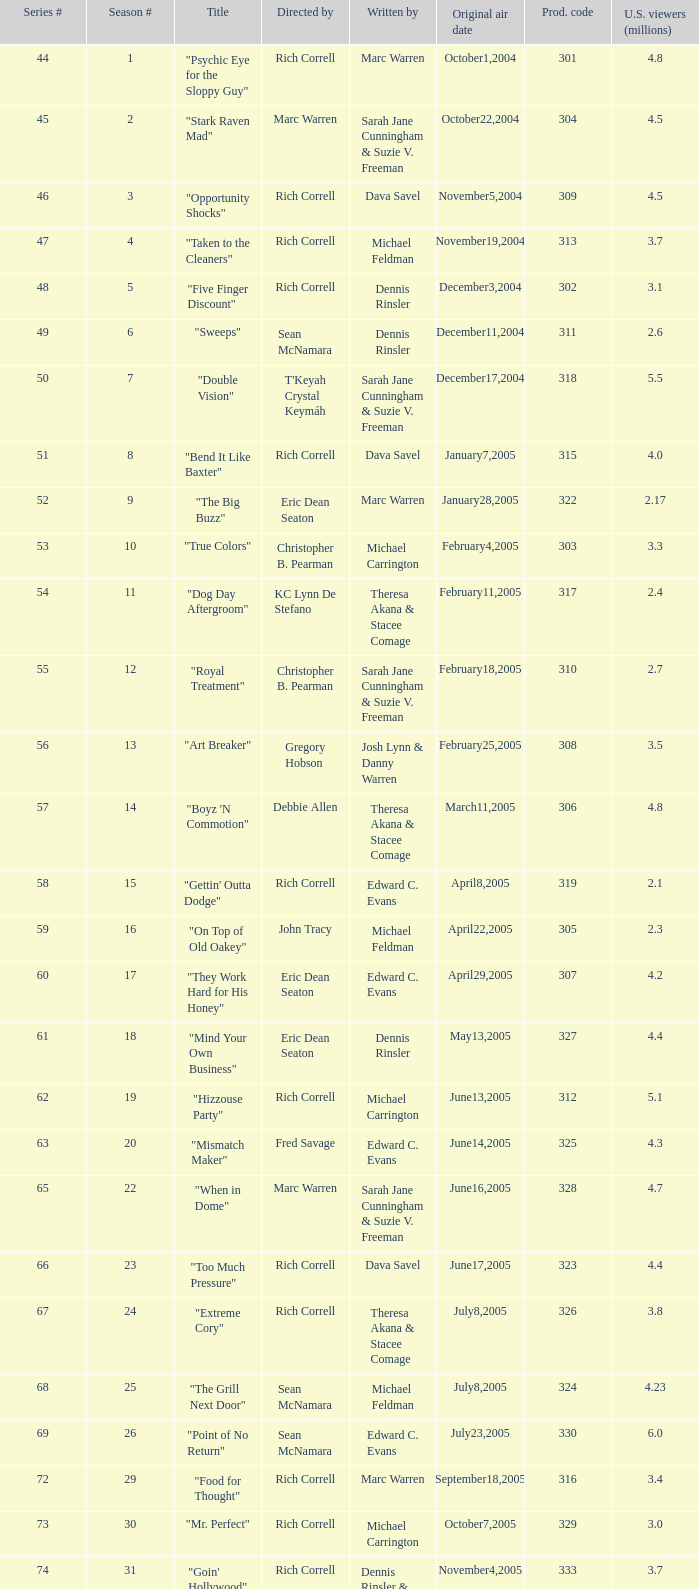Which episode number of the season had the title "vision impossible"? 34.0. 